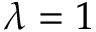Convert formula to latex. <formula><loc_0><loc_0><loc_500><loc_500>\lambda = 1</formula> 